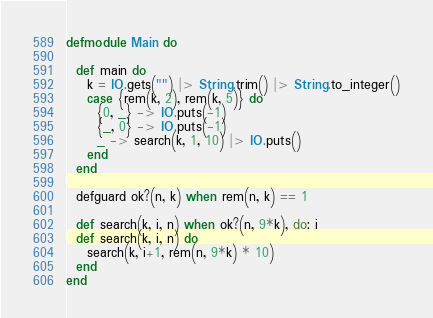<code> <loc_0><loc_0><loc_500><loc_500><_Elixir_>defmodule Main do

  def main do
    k = IO.gets("") |> String.trim() |> String.to_integer()
    case {rem(k, 2), rem(k, 5)} do
      {0, _} -> IO.puts(-1)
      {_, 0} -> IO.puts(-1)
      _ -> search(k, 1, 10) |> IO.puts()
    end
  end

  defguard ok?(n, k) when rem(n, k) == 1

  def search(k, i, n) when ok?(n, 9*k), do: i
  def search(k, i, n) do
    search(k, i+1, rem(n, 9*k) * 10)
  end
end
</code> 